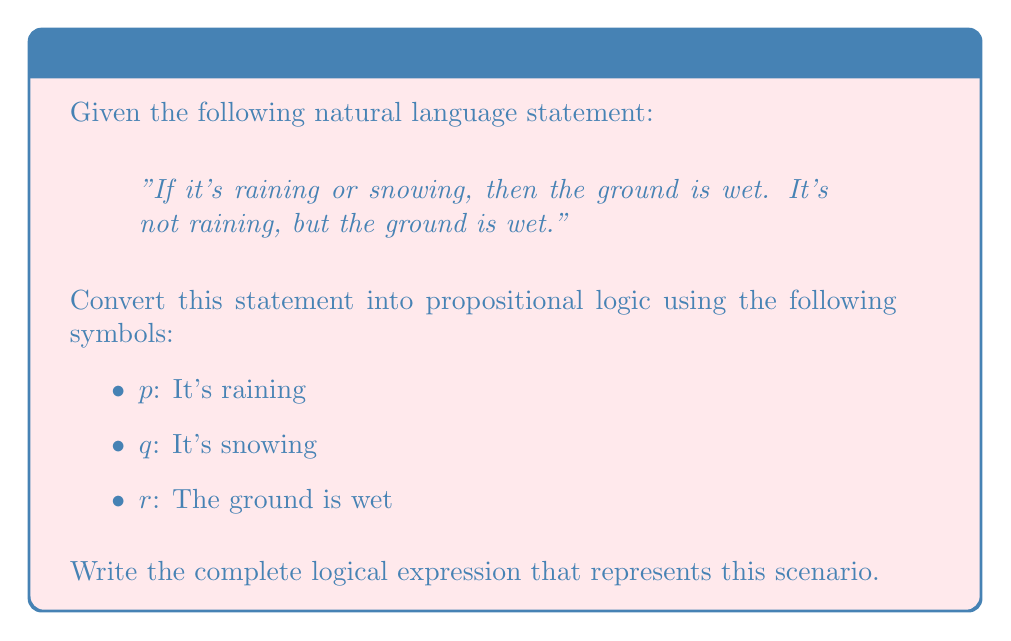Help me with this question. Let's break down the statement and convert it step-by-step:

1. "If it's raining or snowing, then the ground is wet":
   - This is an implication: $(p \lor q) \implies r$

2. "It's not raining":
   - This is a negation: $\lnot p$

3. "The ground is wet":
   - This is a simple statement: $r$

Now, we need to combine these logical expressions using the conjunction (AND) operator, as all of these statements are true simultaneously:

$[(p \lor q) \implies r] \land \lnot p \land r$

In Lua, you might represent this expression as:

```lua
function logicalExpression(p, q, r)
    return (not (p or q) or r) and (not p) and r
end
```

This function would return true if and only if all parts of the logical expression are true.
Answer: $[(p \lor q) \implies r] \land \lnot p \land r$ 